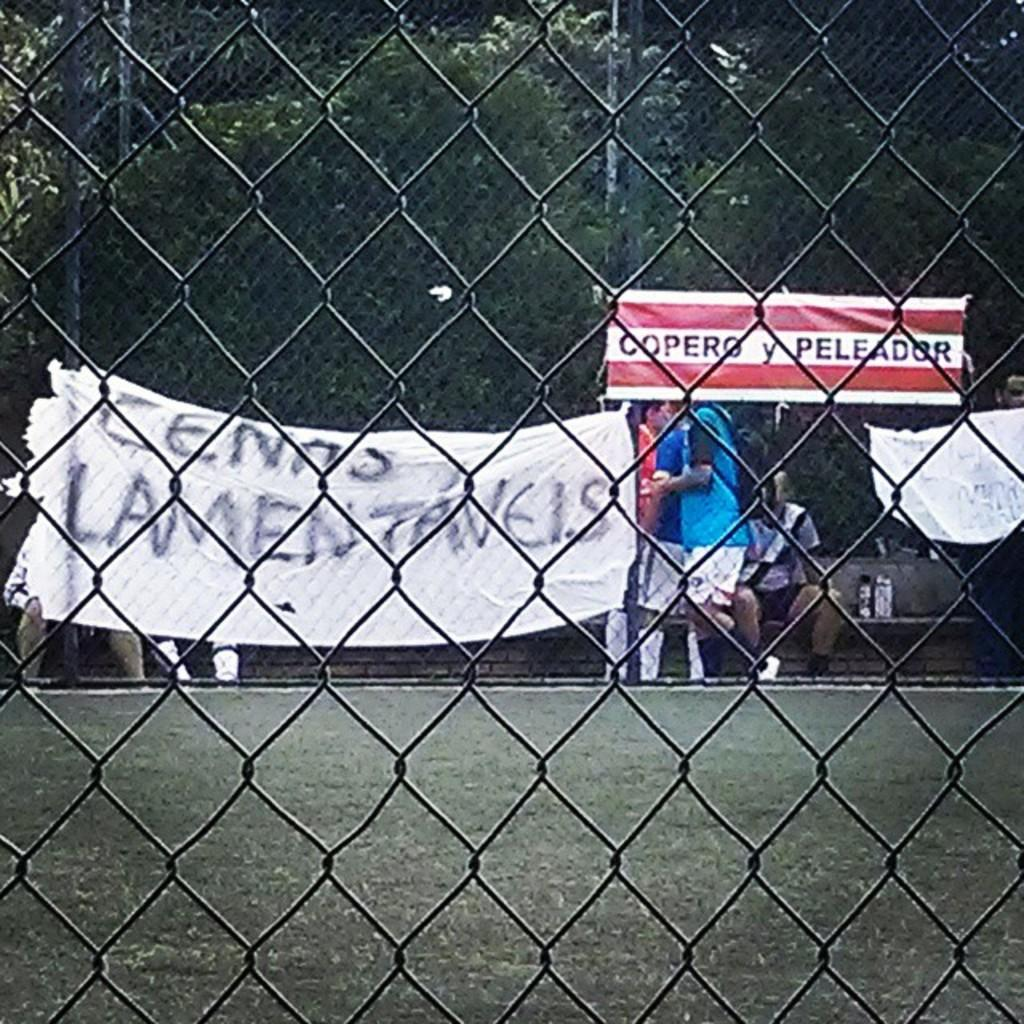What type of structure can be seen in the image? There is fencing in the image. What can be seen in the background of the image? There are banners, people, and trees in the background of the image. What is written on the banners? There is writing on the banners. What type of cheese is being served at the event depicted in the image? There is no cheese or event depicted in the image; it only shows fencing, banners, people, and trees in the background. 